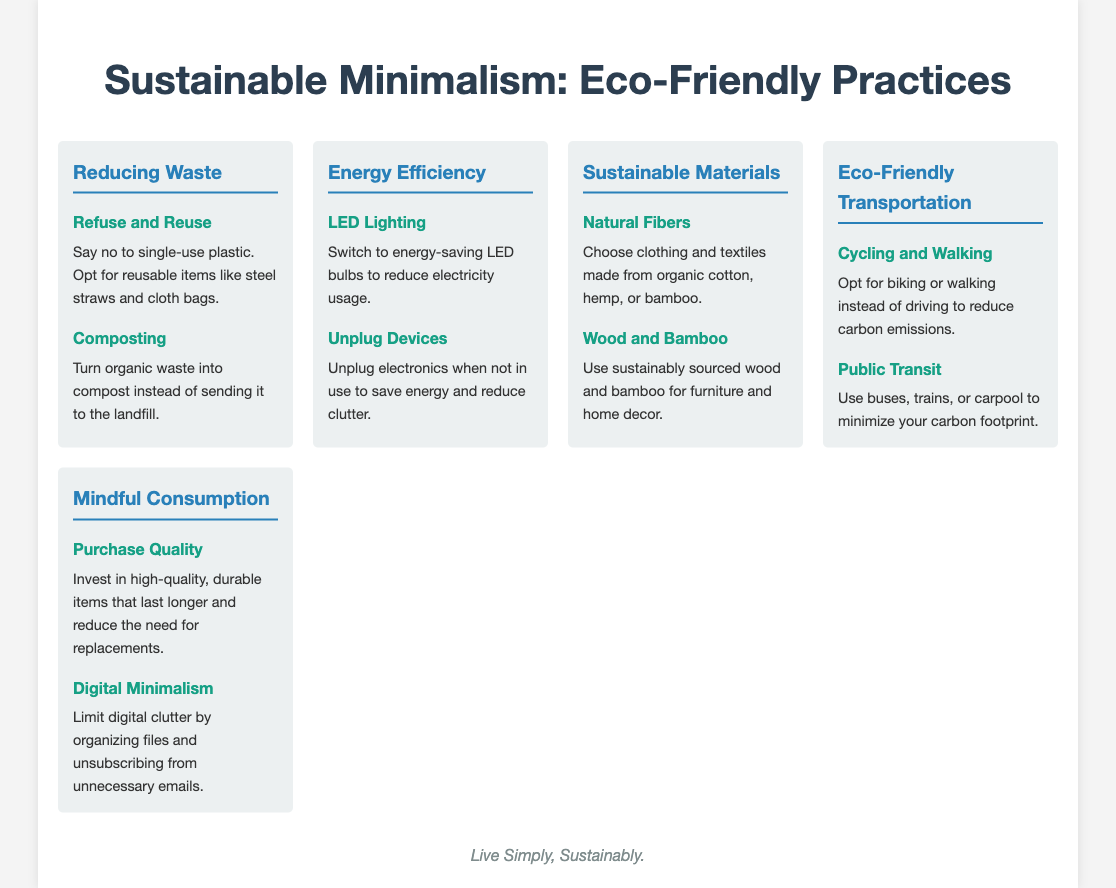What is the main title of the infographic? The title of the infographic clearly states its subject matter, which is about sustainable minimalism and eco-friendly practices.
Answer: Sustainable Minimalism: Eco-Friendly Practices What are two examples of reducing waste practices? The infographic provides specific practices for waste reduction under the "Reducing Waste" section, highlighting ways to refuse and reuse.
Answer: Refuse and Reuse, Composting What type of lighting is recommended for energy efficiency? The document specifies a particular type of lighting that is more energy-efficient, thus contributing to energy savings.
Answer: LED Lighting What are two materials suggested for sustainable products? The infographic mentions specific types of materials that are eco-friendly and sustainable for consumer products.
Answer: Natural Fibers, Wood and Bamboo What is a suggested mode of transport to reduce carbon footprint? The infographic offers one of the modes of transportation that minimizes greenhouse gas emissions.
Answer: Cycling and Walking What does the infographic suggest to enhance mindful consumption? The document presents a practice to promote better consumption choices and reduce purchasing of unnecessary items.
Answer: Purchase Quality What is a practice for reducing digital clutter? The infographic advises on a specific way to manage digital space effectively.
Answer: Digital Minimalism How is the information in the infographic organized? The structure of the infographic categorizes the practices into distinct sections, making it visually clear and organized.
Answer: Sections with headings 